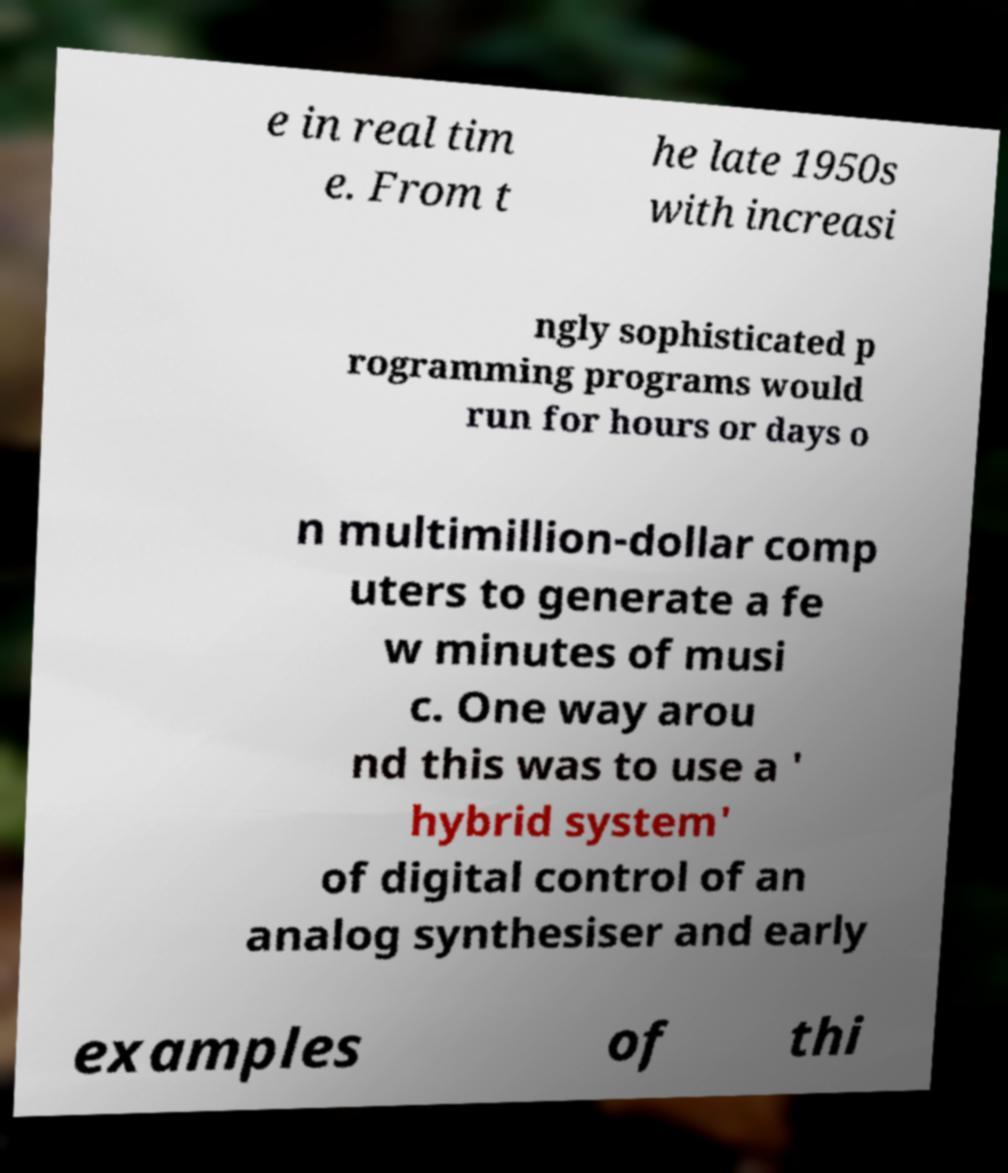Could you assist in decoding the text presented in this image and type it out clearly? e in real tim e. From t he late 1950s with increasi ngly sophisticated p rogramming programs would run for hours or days o n multimillion-dollar comp uters to generate a fe w minutes of musi c. One way arou nd this was to use a ' hybrid system' of digital control of an analog synthesiser and early examples of thi 